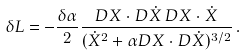Convert formula to latex. <formula><loc_0><loc_0><loc_500><loc_500>\delta L = - { \frac { \delta \alpha } { 2 } } { \frac { D X \cdot D \dot { X } \, D X \cdot \dot { X } } { ( \dot { X } ^ { 2 } + \alpha D X \cdot D \dot { X } ) ^ { 3 / 2 } } } \, .</formula> 